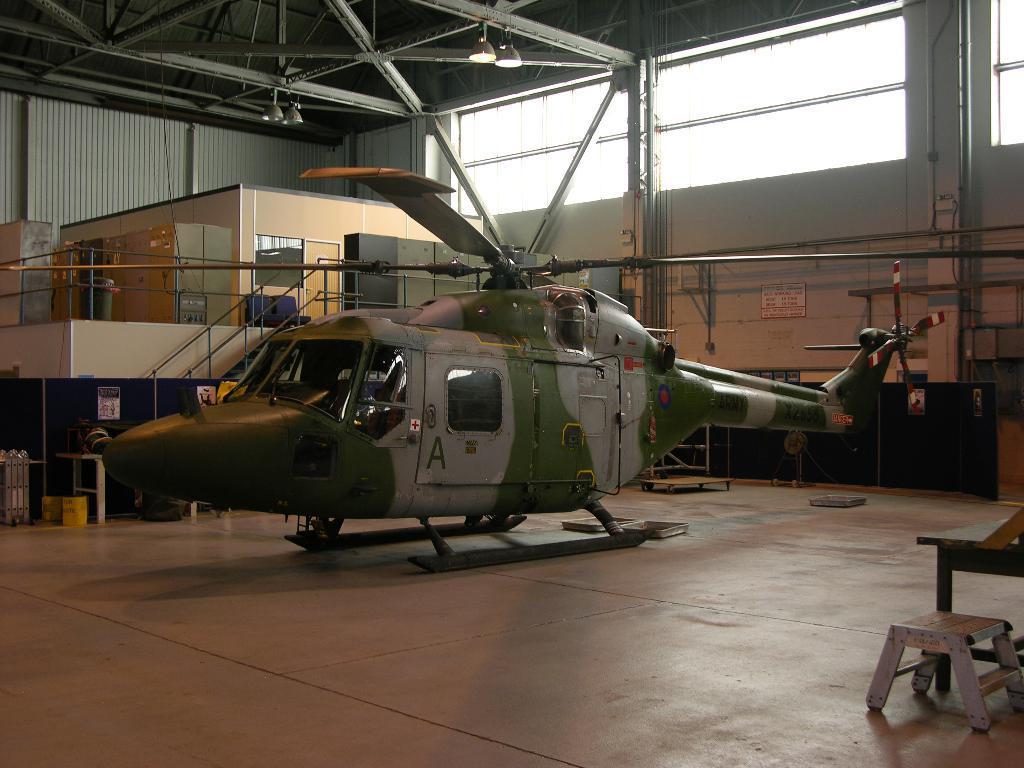Please provide a concise description of this image. In this image we can see a helicopter. In the background of the image there is a room. At the top of the image there are rods and lights to the ceiling. To the right side of the image there is a wall. There is a glass. At the bottom of the image there is floor. To the right side of the image there is table and bench. 